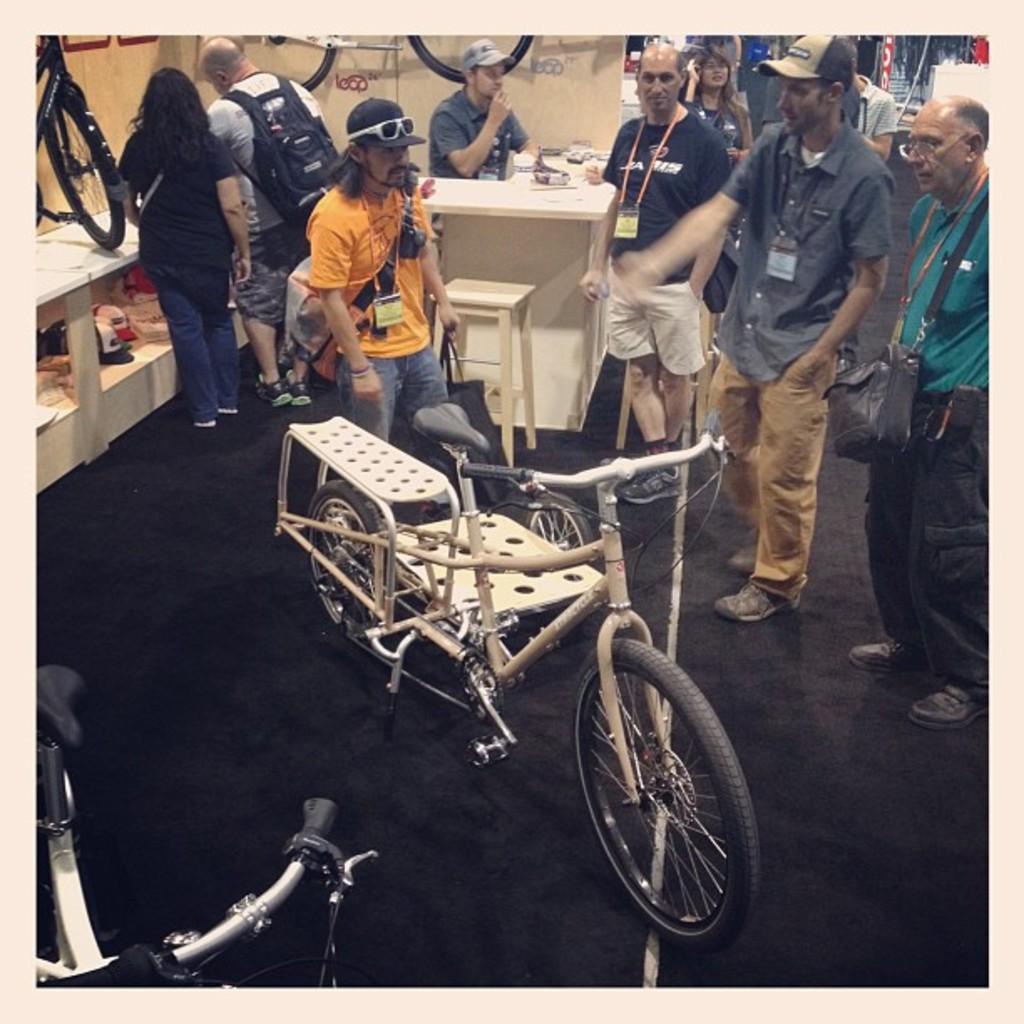In one or two sentences, can you explain what this image depicts? In this image I can see group of people standing. In front I can see a bi-cycle in white color, background I can see few objects on the table and the table is in white color and I can also see few banners. 